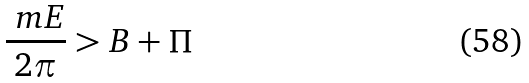<formula> <loc_0><loc_0><loc_500><loc_500>\frac { \ m E } { 2 \pi } > B + \Pi</formula> 